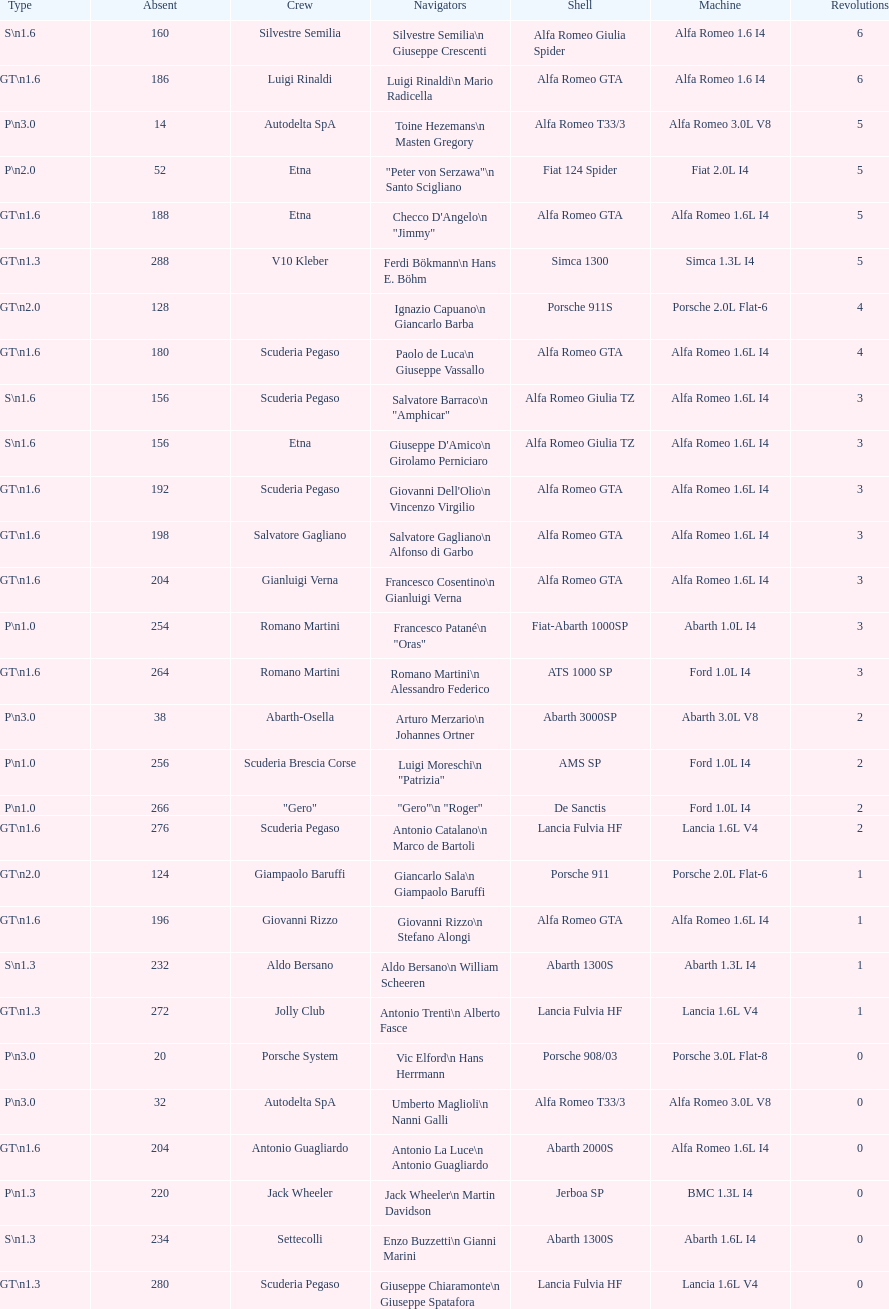Parse the table in full. {'header': ['Type', 'Absent', 'Crew', 'Navigators', 'Shell', 'Machine', 'Revolutions'], 'rows': [['S\\n1.6', '160', 'Silvestre Semilia', 'Silvestre Semilia\\n Giuseppe Crescenti', 'Alfa Romeo Giulia Spider', 'Alfa Romeo 1.6 I4', '6'], ['GT\\n1.6', '186', 'Luigi Rinaldi', 'Luigi Rinaldi\\n Mario Radicella', 'Alfa Romeo GTA', 'Alfa Romeo 1.6 I4', '6'], ['P\\n3.0', '14', 'Autodelta SpA', 'Toine Hezemans\\n Masten Gregory', 'Alfa Romeo T33/3', 'Alfa Romeo 3.0L V8', '5'], ['P\\n2.0', '52', 'Etna', '"Peter von Serzawa"\\n Santo Scigliano', 'Fiat 124 Spider', 'Fiat 2.0L I4', '5'], ['GT\\n1.6', '188', 'Etna', 'Checco D\'Angelo\\n "Jimmy"', 'Alfa Romeo GTA', 'Alfa Romeo 1.6L I4', '5'], ['GT\\n1.3', '288', 'V10 Kleber', 'Ferdi Bökmann\\n Hans E. Böhm', 'Simca 1300', 'Simca 1.3L I4', '5'], ['GT\\n2.0', '128', '', 'Ignazio Capuano\\n Giancarlo Barba', 'Porsche 911S', 'Porsche 2.0L Flat-6', '4'], ['GT\\n1.6', '180', 'Scuderia Pegaso', 'Paolo de Luca\\n Giuseppe Vassallo', 'Alfa Romeo GTA', 'Alfa Romeo 1.6L I4', '4'], ['S\\n1.6', '156', 'Scuderia Pegaso', 'Salvatore Barraco\\n "Amphicar"', 'Alfa Romeo Giulia TZ', 'Alfa Romeo 1.6L I4', '3'], ['S\\n1.6', '156', 'Etna', "Giuseppe D'Amico\\n Girolamo Perniciaro", 'Alfa Romeo Giulia TZ', 'Alfa Romeo 1.6L I4', '3'], ['GT\\n1.6', '192', 'Scuderia Pegaso', "Giovanni Dell'Olio\\n Vincenzo Virgilio", 'Alfa Romeo GTA', 'Alfa Romeo 1.6L I4', '3'], ['GT\\n1.6', '198', 'Salvatore Gagliano', 'Salvatore Gagliano\\n Alfonso di Garbo', 'Alfa Romeo GTA', 'Alfa Romeo 1.6L I4', '3'], ['GT\\n1.6', '204', 'Gianluigi Verna', 'Francesco Cosentino\\n Gianluigi Verna', 'Alfa Romeo GTA', 'Alfa Romeo 1.6L I4', '3'], ['P\\n1.0', '254', 'Romano Martini', 'Francesco Patané\\n "Oras"', 'Fiat-Abarth 1000SP', 'Abarth 1.0L I4', '3'], ['GT\\n1.6', '264', 'Romano Martini', 'Romano Martini\\n Alessandro Federico', 'ATS 1000 SP', 'Ford 1.0L I4', '3'], ['P\\n3.0', '38', 'Abarth-Osella', 'Arturo Merzario\\n Johannes Ortner', 'Abarth 3000SP', 'Abarth 3.0L V8', '2'], ['P\\n1.0', '256', 'Scuderia Brescia Corse', 'Luigi Moreschi\\n "Patrizia"', 'AMS SP', 'Ford 1.0L I4', '2'], ['P\\n1.0', '266', '"Gero"', '"Gero"\\n "Roger"', 'De Sanctis', 'Ford 1.0L I4', '2'], ['GT\\n1.6', '276', 'Scuderia Pegaso', 'Antonio Catalano\\n Marco de Bartoli', 'Lancia Fulvia HF', 'Lancia 1.6L V4', '2'], ['GT\\n2.0', '124', 'Giampaolo Baruffi', 'Giancarlo Sala\\n Giampaolo Baruffi', 'Porsche 911', 'Porsche 2.0L Flat-6', '1'], ['GT\\n1.6', '196', 'Giovanni Rizzo', 'Giovanni Rizzo\\n Stefano Alongi', 'Alfa Romeo GTA', 'Alfa Romeo 1.6L I4', '1'], ['S\\n1.3', '232', 'Aldo Bersano', 'Aldo Bersano\\n William Scheeren', 'Abarth 1300S', 'Abarth 1.3L I4', '1'], ['GT\\n1.3', '272', 'Jolly Club', 'Antonio Trenti\\n Alberto Fasce', 'Lancia Fulvia HF', 'Lancia 1.6L V4', '1'], ['P\\n3.0', '20', 'Porsche System', 'Vic Elford\\n Hans Herrmann', 'Porsche 908/03', 'Porsche 3.0L Flat-8', '0'], ['P\\n3.0', '32', 'Autodelta SpA', 'Umberto Maglioli\\n Nanni Galli', 'Alfa Romeo T33/3', 'Alfa Romeo 3.0L V8', '0'], ['GT\\n1.6', '204', 'Antonio Guagliardo', 'Antonio La Luce\\n Antonio Guagliardo', 'Abarth 2000S', 'Alfa Romeo 1.6L I4', '0'], ['P\\n1.3', '220', 'Jack Wheeler', 'Jack Wheeler\\n Martin Davidson', 'Jerboa SP', 'BMC 1.3L I4', '0'], ['S\\n1.3', '234', 'Settecolli', 'Enzo Buzzetti\\n Gianni Marini', 'Abarth 1300S', 'Abarth 1.6L I4', '0'], ['GT\\n1.3', '280', 'Scuderia Pegaso', 'Giuseppe Chiaramonte\\n Giuseppe Spatafora', 'Lancia Fulvia HF', 'Lancia 1.6L V4', '0']]} What class is below s 1.6? GT 1.6. 